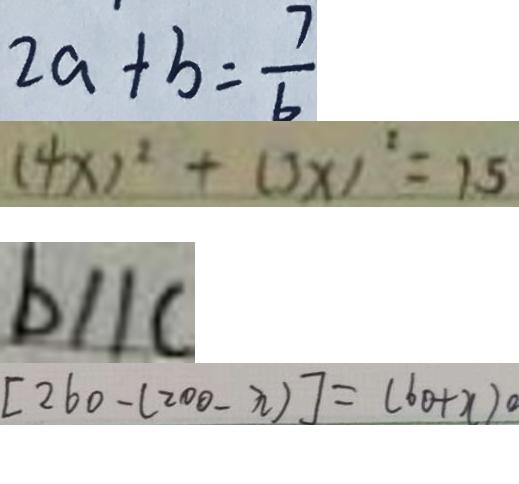Convert formula to latex. <formula><loc_0><loc_0><loc_500><loc_500>2 a + b = \frac { 7 } { 6 } 
 ( 4 x ) ^ { 2 } + ( 3 x ) ^ { 2 } = 1 . 5 
 b / / c 
 [ 2 6 0 - ( 2 0 0 - n ) ] = ( 6 0 + x ) 0</formula> 